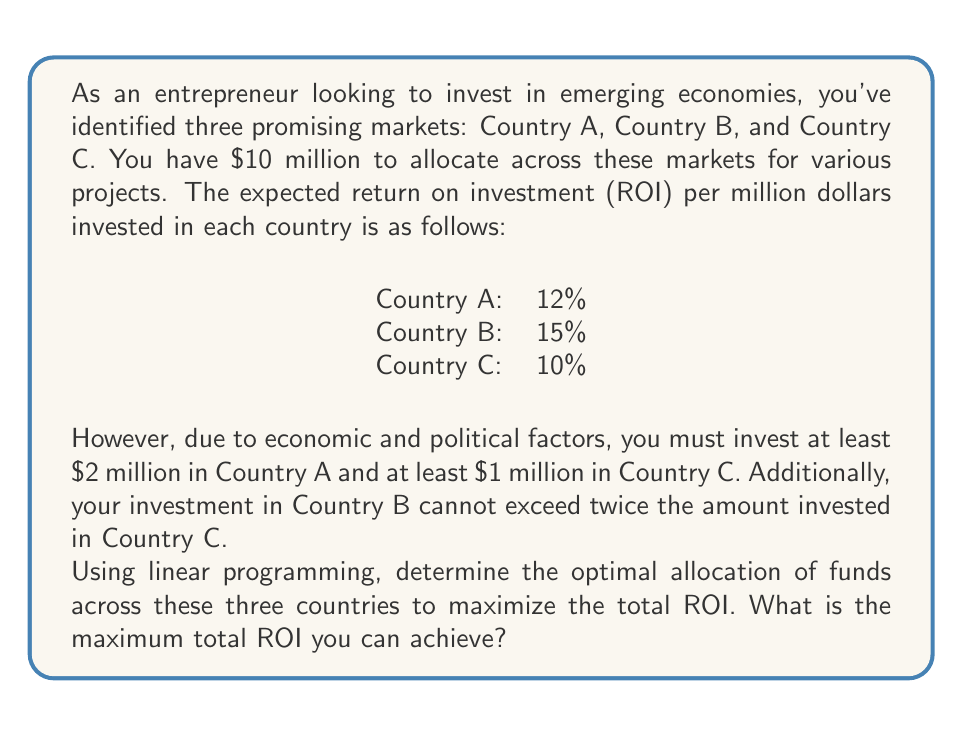Teach me how to tackle this problem. Let's approach this problem using linear programming:

1. Define variables:
   Let $x_A$, $x_B$, and $x_C$ be the amounts (in millions) invested in Countries A, B, and C respectively.

2. Objective function:
   Maximize $Z = 0.12x_A + 0.15x_B + 0.10x_C$

3. Constraints:
   a) Total investment: $x_A + x_B + x_C = 10$
   b) Minimum investment in A: $x_A \geq 2$
   c) Minimum investment in C: $x_C \geq 1$
   d) B's investment limit: $x_B \leq 2x_C$
   e) Non-negativity: $x_A, x_B, x_C \geq 0$

4. Solve using the simplex method or graphical method:

   Given the constraints, we can deduce:
   - $x_A \geq 2$
   - $x_C \geq 1$
   - $x_B \leq 2x_C$
   - $x_B \leq 10 - x_A - x_C$

   The optimal solution will likely occur at the intersection of these constraints.

   Try: $x_A = 2, x_C = 1, x_B = 2x_C = 2$
   This doesn't use all the funds. We can increase $x_B$:

   Optimal solution: $x_A = 2, x_C = 2.67, x_B = 5.33$

5. Calculate the maximum ROI:
   $Z = 0.12(2) + 0.15(5.33) + 0.10(2.67)$
   $Z = 0.24 + 0.8 + 0.267 = 1.307$ or 13.07%

Therefore, the maximum total ROI is 13.07%.
Answer: The maximum total ROI that can be achieved is 13.07%. 